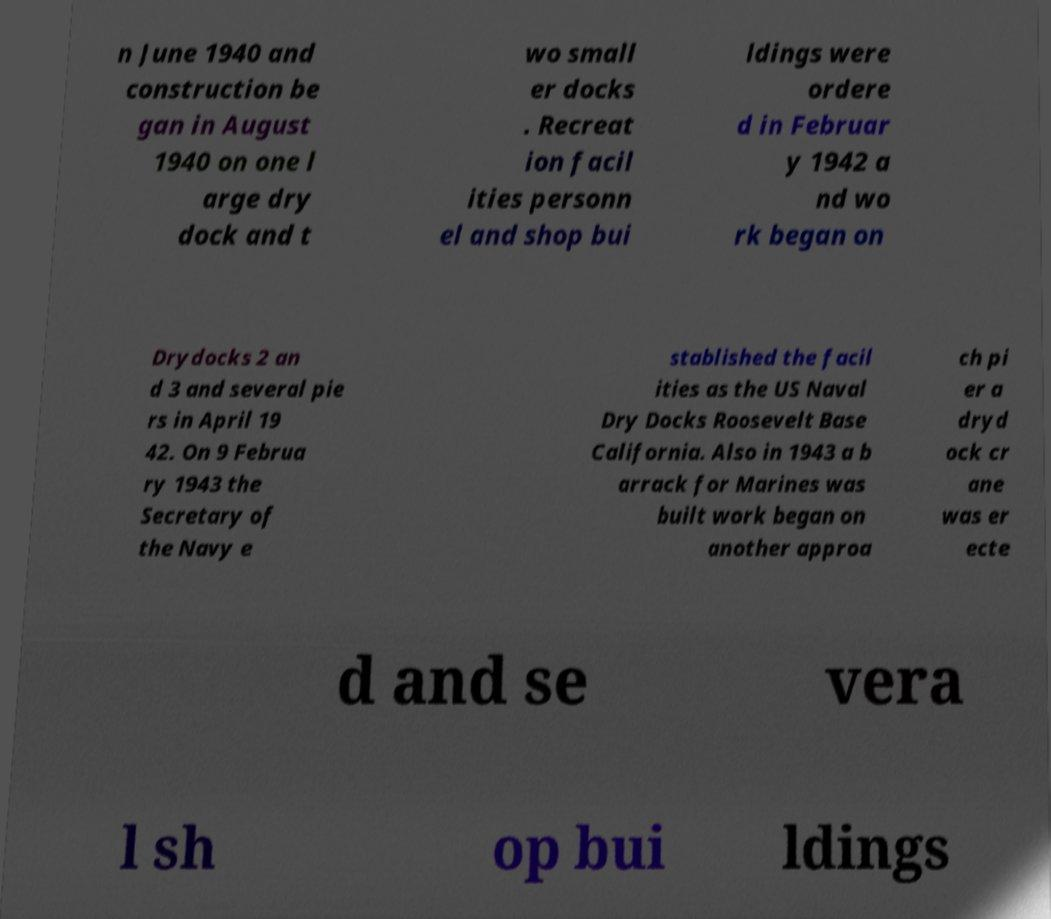Could you extract and type out the text from this image? n June 1940 and construction be gan in August 1940 on one l arge dry dock and t wo small er docks . Recreat ion facil ities personn el and shop bui ldings were ordere d in Februar y 1942 a nd wo rk began on Drydocks 2 an d 3 and several pie rs in April 19 42. On 9 Februa ry 1943 the Secretary of the Navy e stablished the facil ities as the US Naval Dry Docks Roosevelt Base California. Also in 1943 a b arrack for Marines was built work began on another approa ch pi er a dryd ock cr ane was er ecte d and se vera l sh op bui ldings 